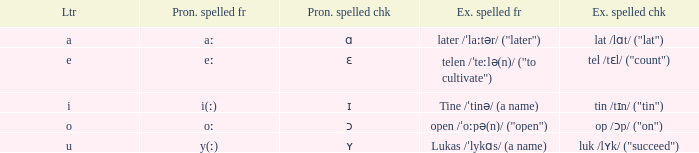What is Letter, when Example Spelled Checked is "tin /tɪn/ ("tin")"? I. 